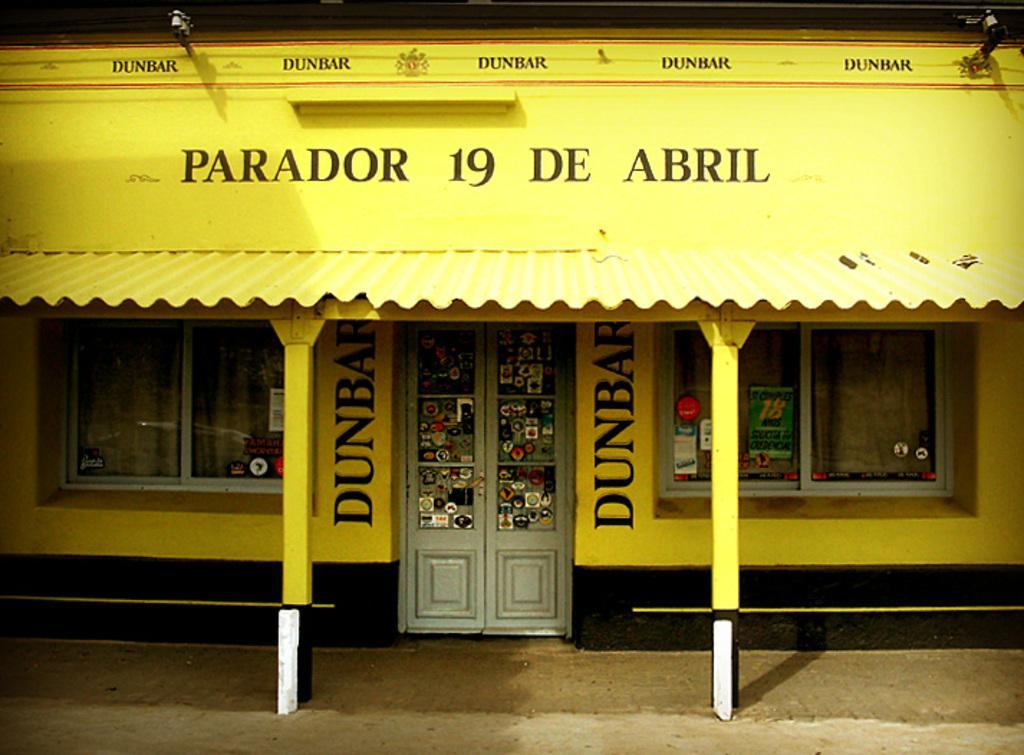How would you summarize this image in a sentence or two? In the foreground I can see a house, pillars, windows, door and a text. This image is taken may be during night. 